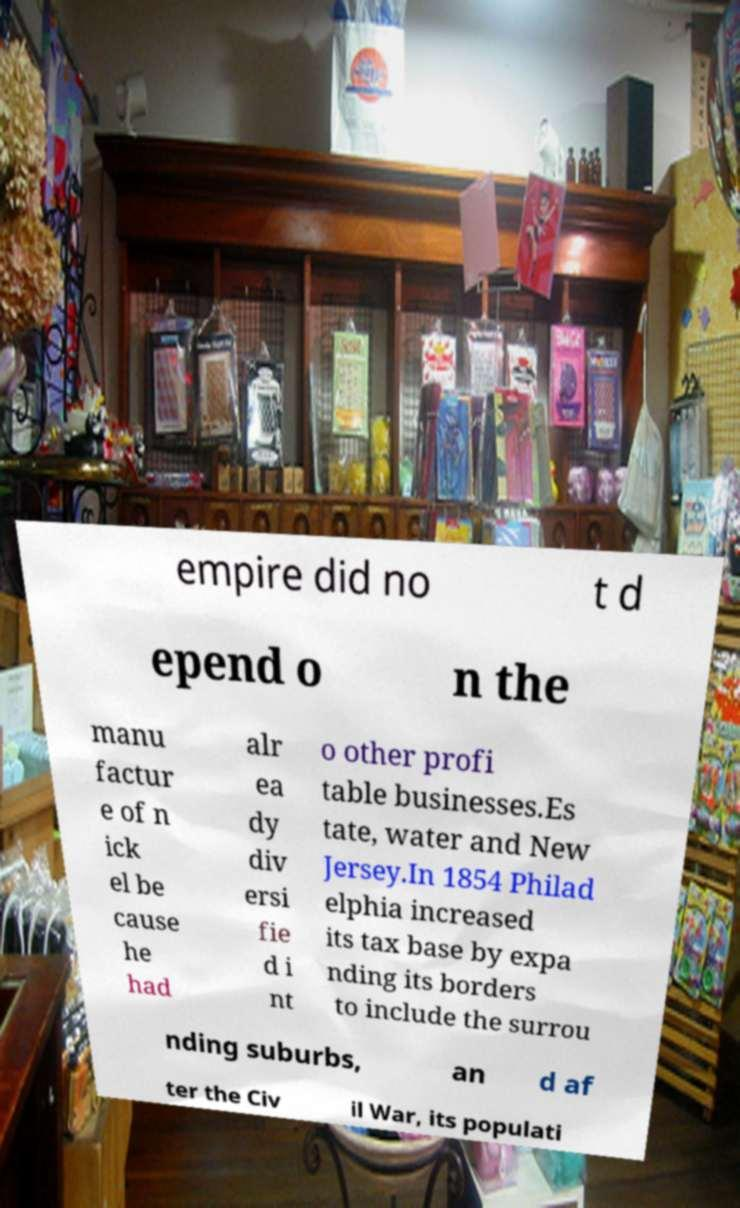There's text embedded in this image that I need extracted. Can you transcribe it verbatim? empire did no t d epend o n the manu factur e of n ick el be cause he had alr ea dy div ersi fie d i nt o other profi table businesses.Es tate, water and New Jersey.In 1854 Philad elphia increased its tax base by expa nding its borders to include the surrou nding suburbs, an d af ter the Civ il War, its populati 